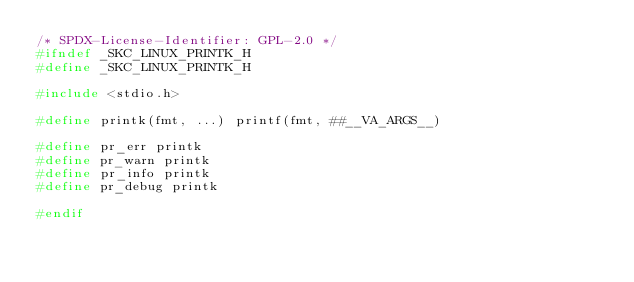Convert code to text. <code><loc_0><loc_0><loc_500><loc_500><_C_>/* SPDX-License-Identifier: GPL-2.0 */
#ifndef _SKC_LINUX_PRINTK_H
#define _SKC_LINUX_PRINTK_H

#include <stdio.h>

#define printk(fmt, ...) printf(fmt, ##__VA_ARGS__)

#define pr_err printk
#define pr_warn	printk
#define pr_info	printk
#define pr_debug printk

#endif
</code> 